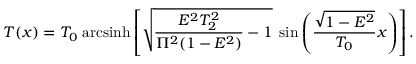Convert formula to latex. <formula><loc_0><loc_0><loc_500><loc_500>T ( x ) = T _ { 0 } \, a r c \sinh \left [ \sqrt { \frac { E ^ { 2 } T _ { 2 } ^ { 2 } } { \Pi ^ { 2 } ( 1 - E ^ { 2 } ) } - 1 } \, \sin \left ( \frac { \sqrt { 1 - E ^ { 2 } } } { T _ { 0 } } x \right ) \right ] .</formula> 